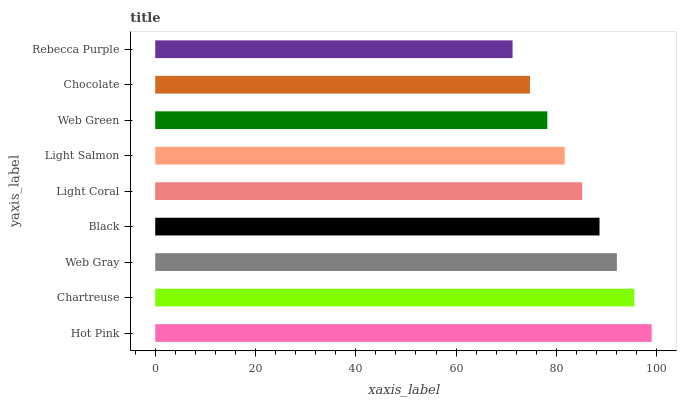Is Rebecca Purple the minimum?
Answer yes or no. Yes. Is Hot Pink the maximum?
Answer yes or no. Yes. Is Chartreuse the minimum?
Answer yes or no. No. Is Chartreuse the maximum?
Answer yes or no. No. Is Hot Pink greater than Chartreuse?
Answer yes or no. Yes. Is Chartreuse less than Hot Pink?
Answer yes or no. Yes. Is Chartreuse greater than Hot Pink?
Answer yes or no. No. Is Hot Pink less than Chartreuse?
Answer yes or no. No. Is Light Coral the high median?
Answer yes or no. Yes. Is Light Coral the low median?
Answer yes or no. Yes. Is Black the high median?
Answer yes or no. No. Is Hot Pink the low median?
Answer yes or no. No. 